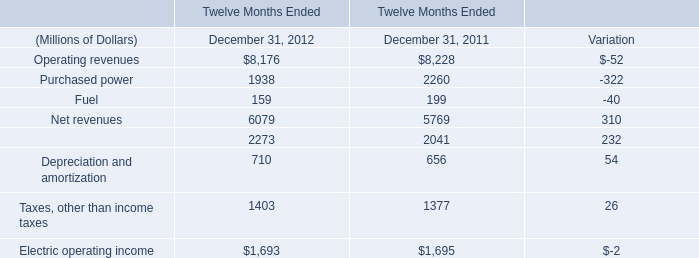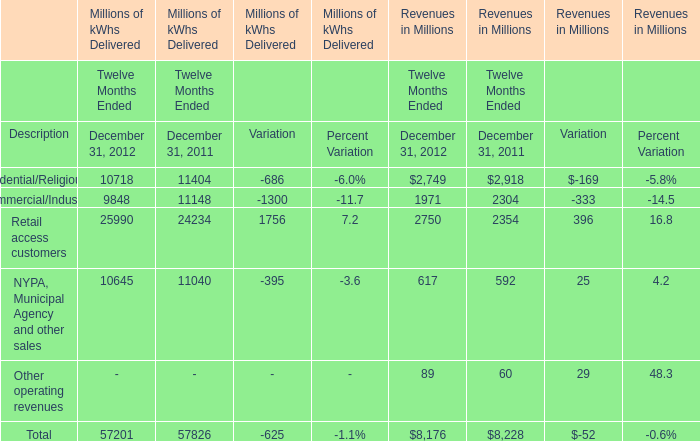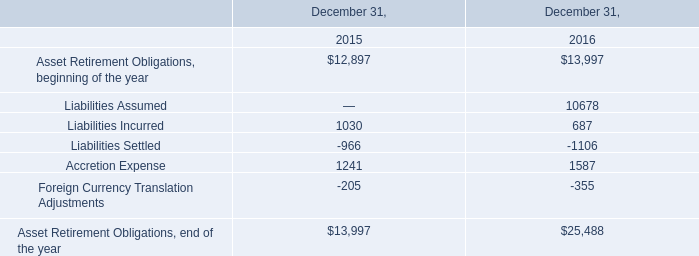what was the ratio of the increase in the operating profit for m&fc to pt&ts 
Computations: (80 / 10)
Answer: 8.0. 